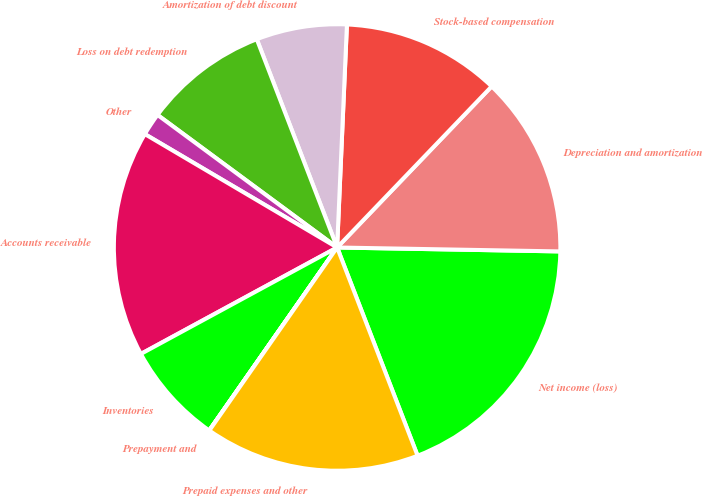<chart> <loc_0><loc_0><loc_500><loc_500><pie_chart><fcel>Net income (loss)<fcel>Depreciation and amortization<fcel>Stock-based compensation<fcel>Amortization of debt discount<fcel>Loss on debt redemption<fcel>Other<fcel>Accounts receivable<fcel>Inventories<fcel>Prepayment and<fcel>Prepaid expenses and other<nl><fcel>18.85%<fcel>13.11%<fcel>11.47%<fcel>6.56%<fcel>9.02%<fcel>1.64%<fcel>16.39%<fcel>7.38%<fcel>0.01%<fcel>15.57%<nl></chart> 